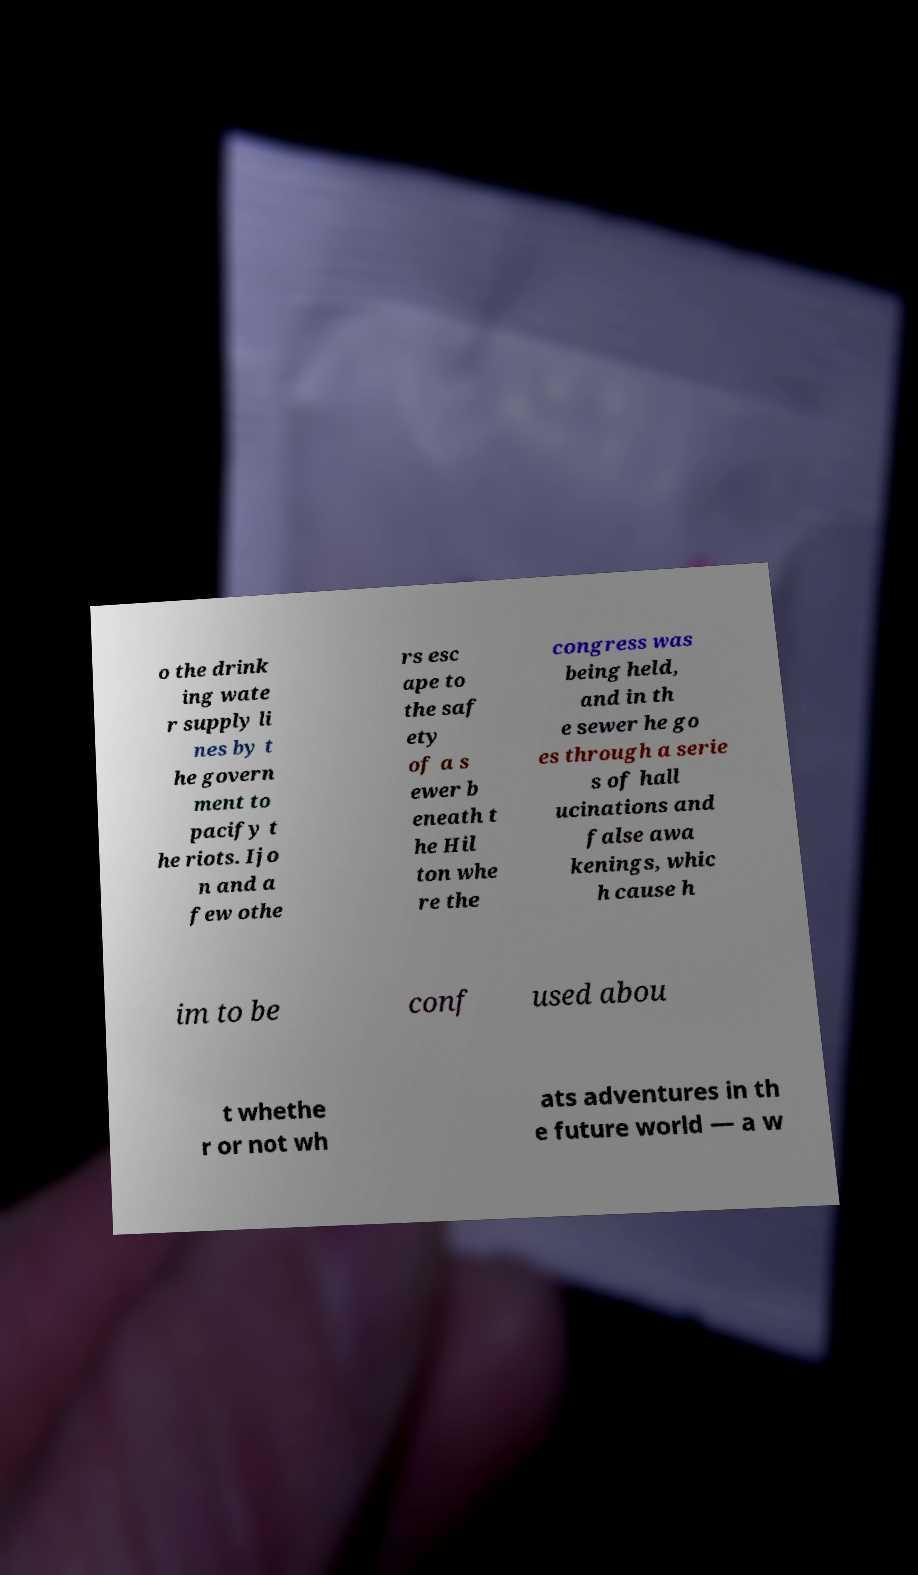Could you extract and type out the text from this image? o the drink ing wate r supply li nes by t he govern ment to pacify t he riots. Ijo n and a few othe rs esc ape to the saf ety of a s ewer b eneath t he Hil ton whe re the congress was being held, and in th e sewer he go es through a serie s of hall ucinations and false awa kenings, whic h cause h im to be conf used abou t whethe r or not wh ats adventures in th e future world — a w 